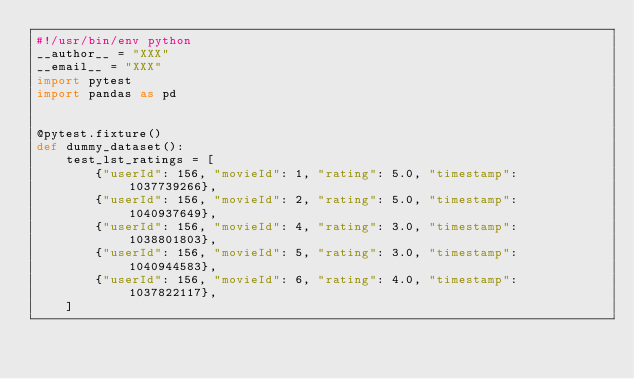<code> <loc_0><loc_0><loc_500><loc_500><_Python_>#!/usr/bin/env python
__author__ = "XXX"
__email__ = "XXX"
import pytest
import pandas as pd


@pytest.fixture()
def dummy_dataset():
    test_lst_ratings = [
        {"userId": 156, "movieId": 1, "rating": 5.0, "timestamp": 1037739266},
        {"userId": 156, "movieId": 2, "rating": 5.0, "timestamp": 1040937649},
        {"userId": 156, "movieId": 4, "rating": 3.0, "timestamp": 1038801803},
        {"userId": 156, "movieId": 5, "rating": 3.0, "timestamp": 1040944583},
        {"userId": 156, "movieId": 6, "rating": 4.0, "timestamp": 1037822117},
    ]
</code> 